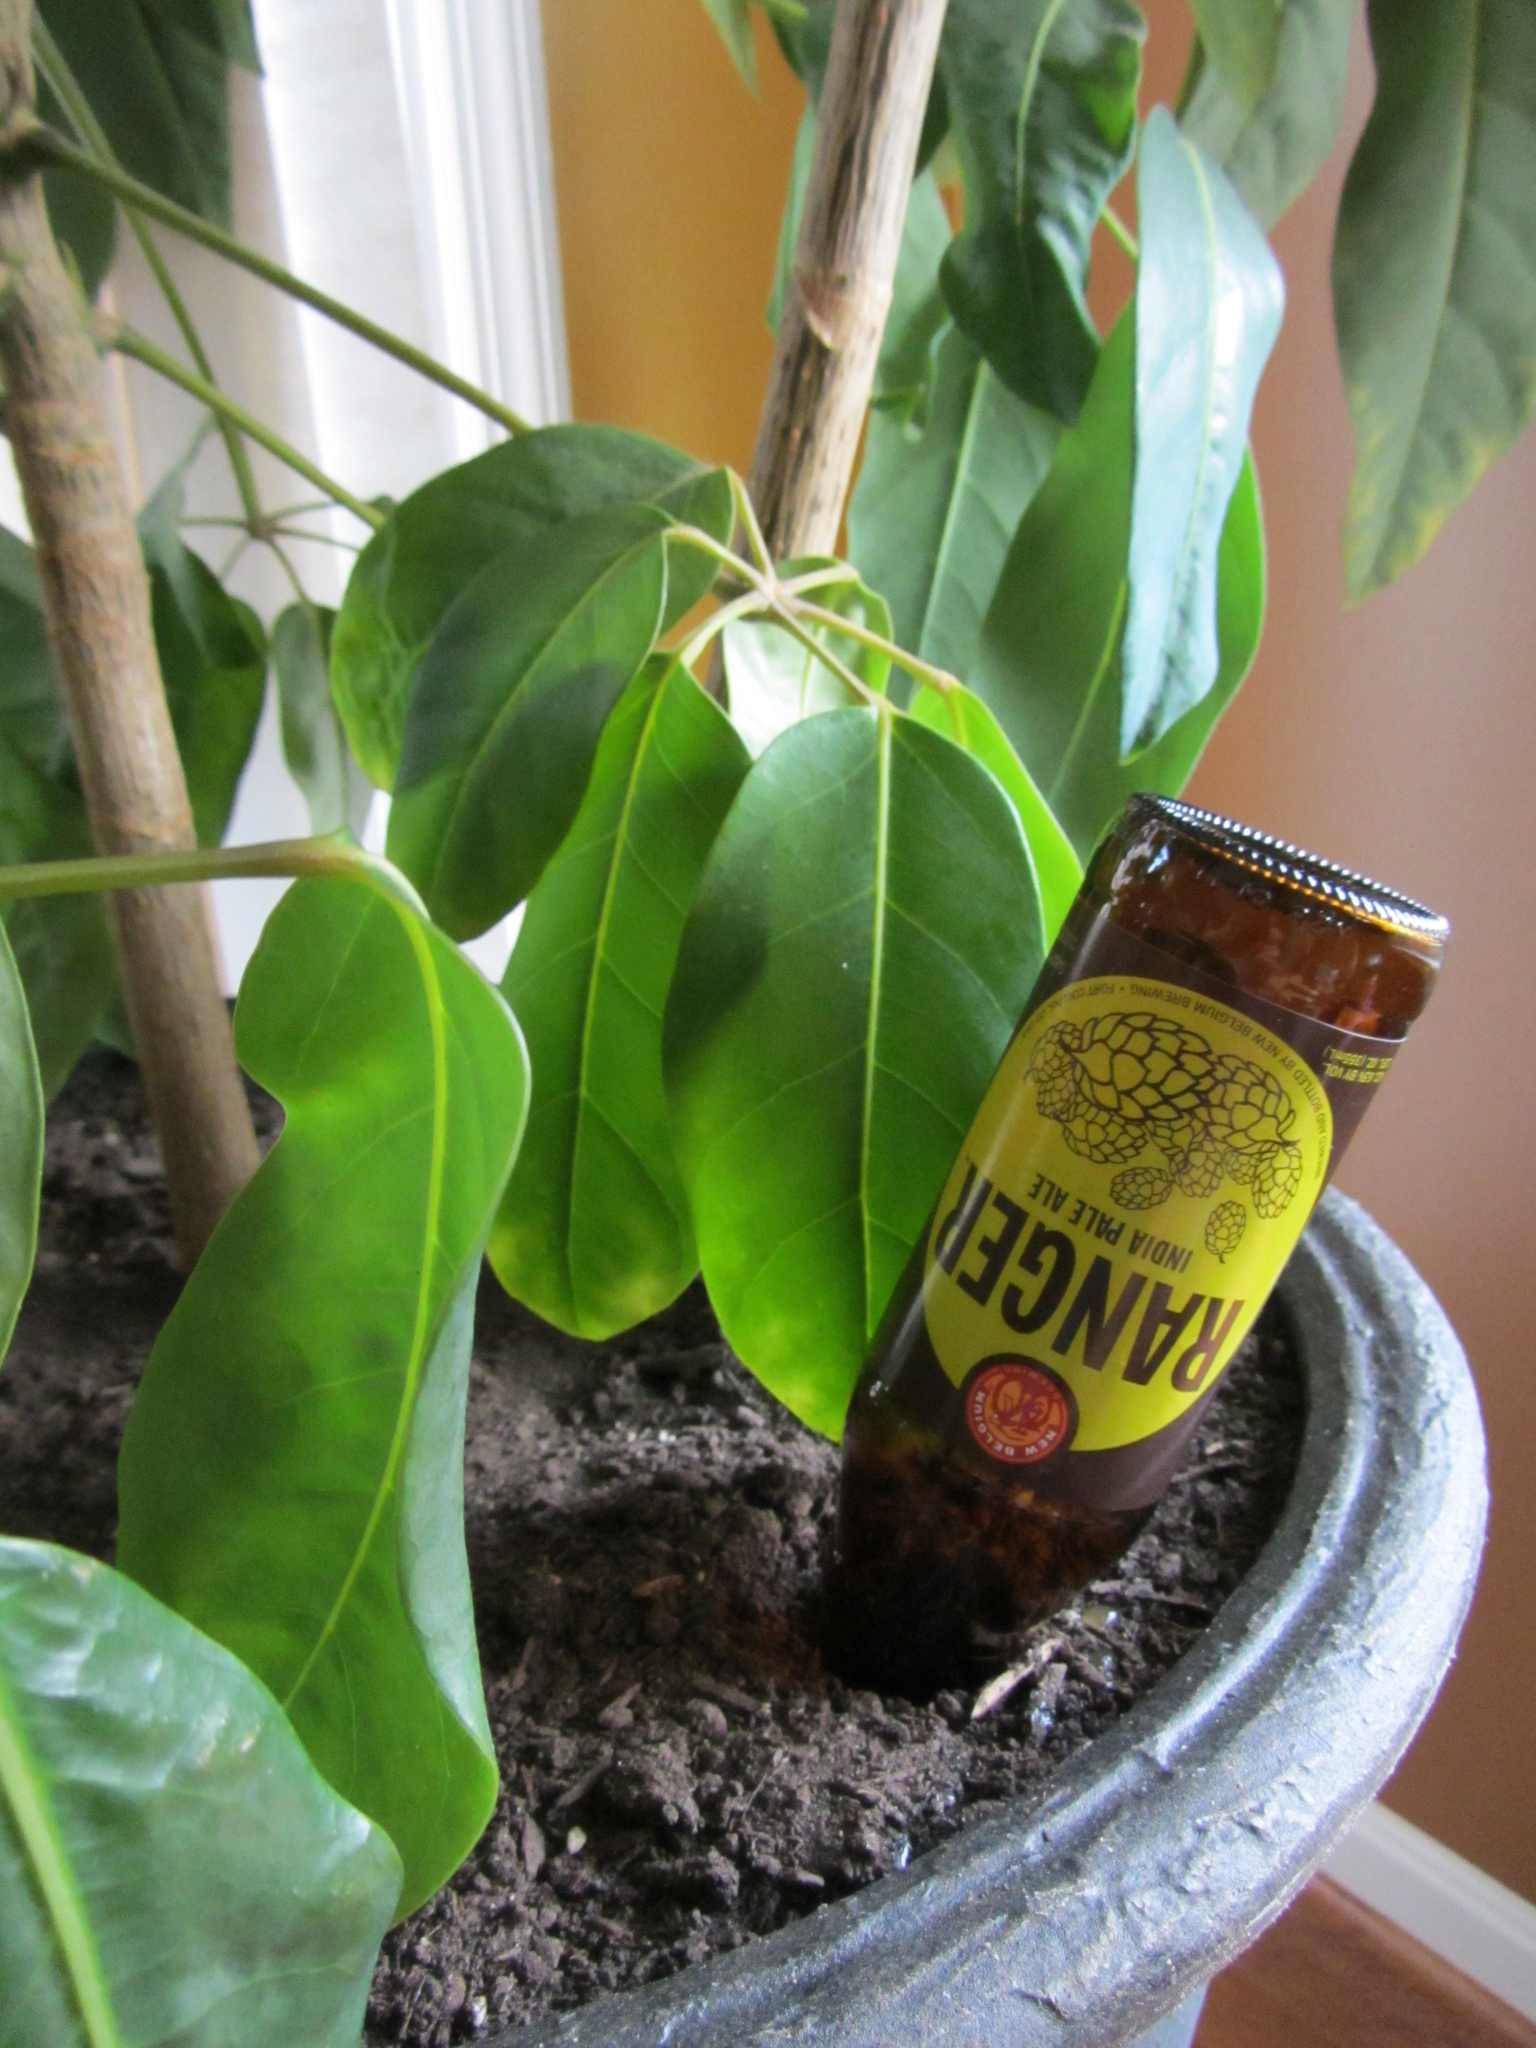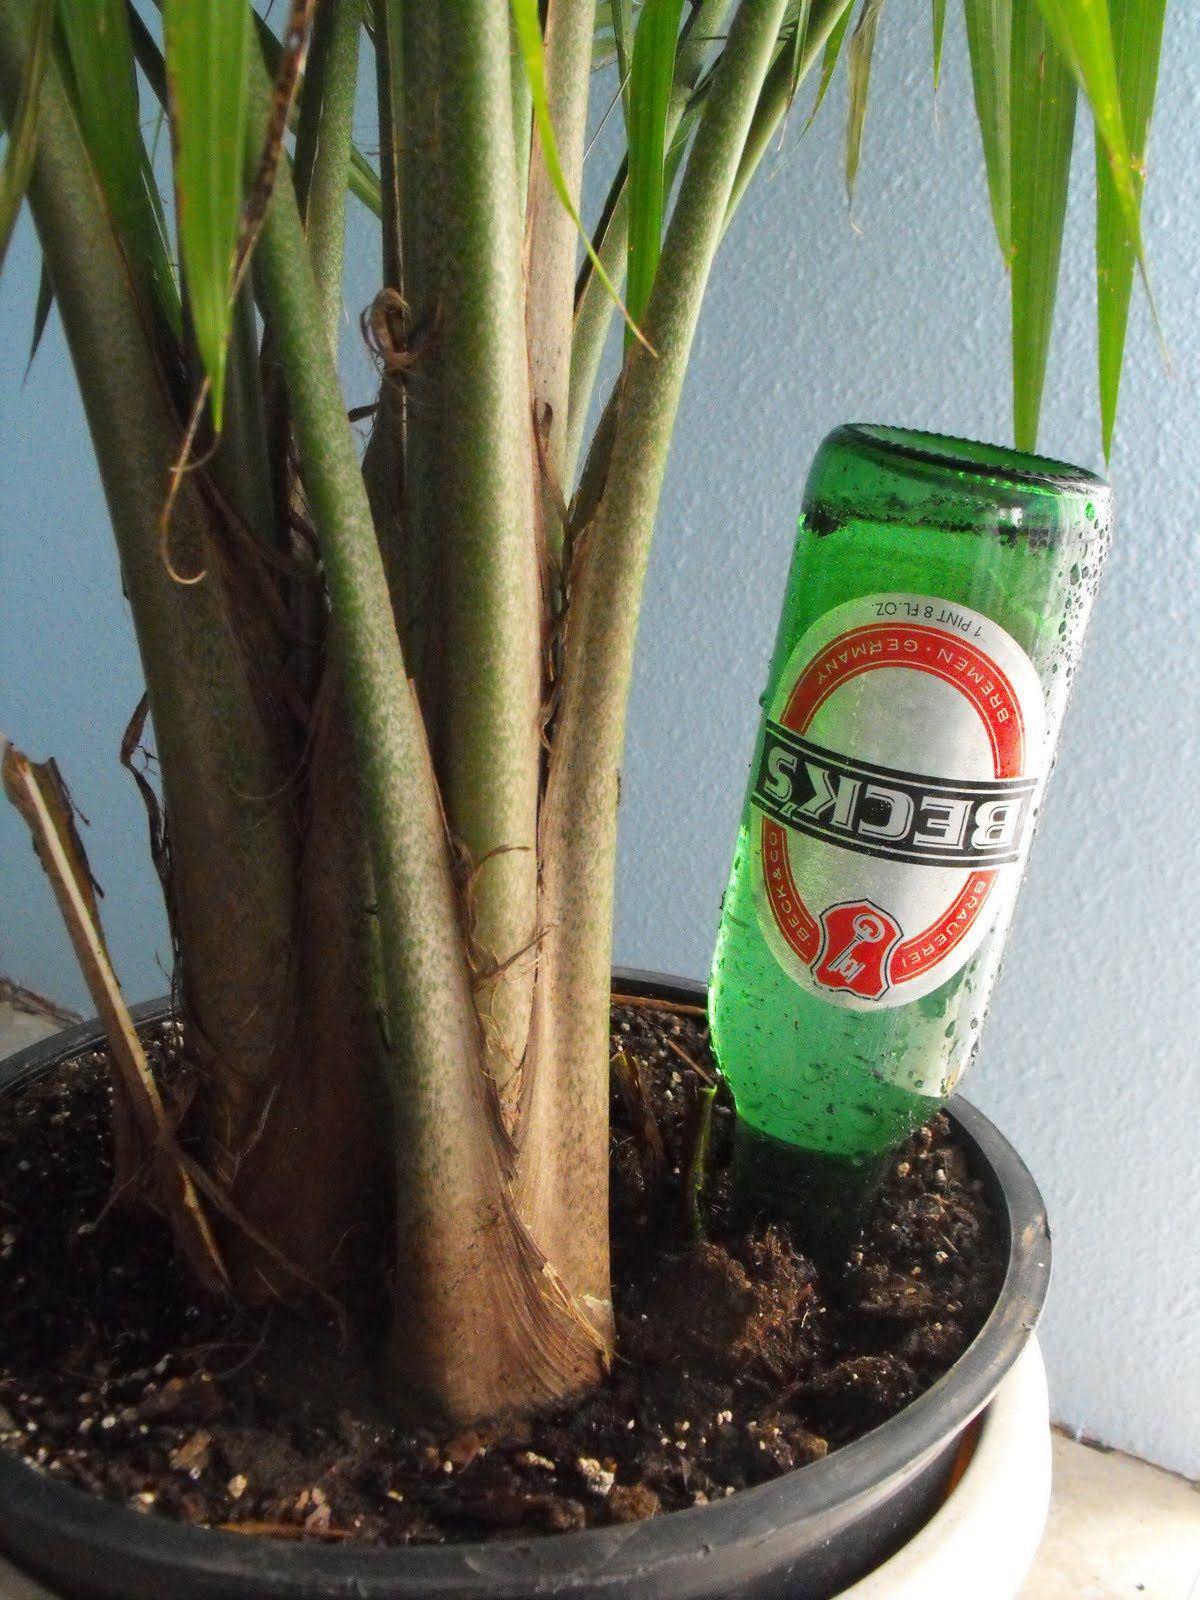The first image is the image on the left, the second image is the image on the right. Given the left and right images, does the statement "A single bottle in the image on the right is positioned upside down." hold true? Answer yes or no. Yes. The first image is the image on the left, the second image is the image on the right. Assess this claim about the two images: "In at least one image there are three brown bottles with tree starting to grow out of it.". Correct or not? Answer yes or no. No. 